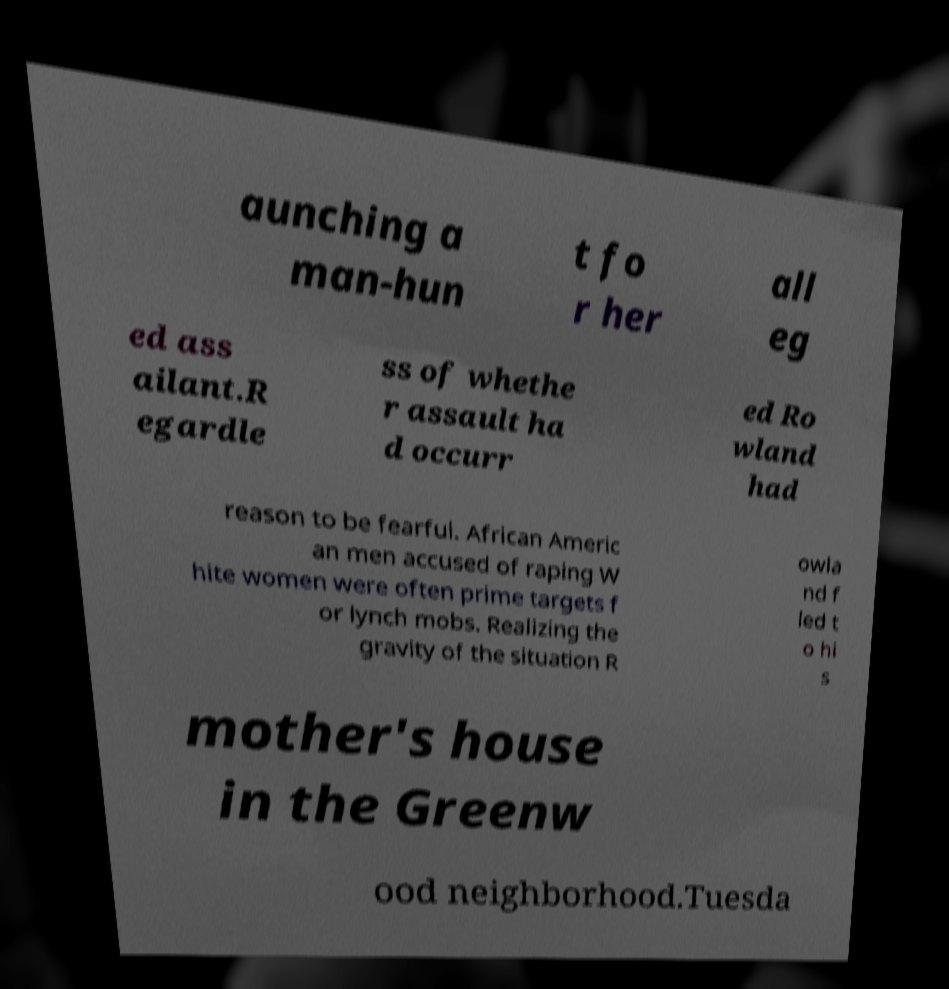Could you extract and type out the text from this image? aunching a man-hun t fo r her all eg ed ass ailant.R egardle ss of whethe r assault ha d occurr ed Ro wland had reason to be fearful. African Americ an men accused of raping W hite women were often prime targets f or lynch mobs. Realizing the gravity of the situation R owla nd f led t o hi s mother's house in the Greenw ood neighborhood.Tuesda 